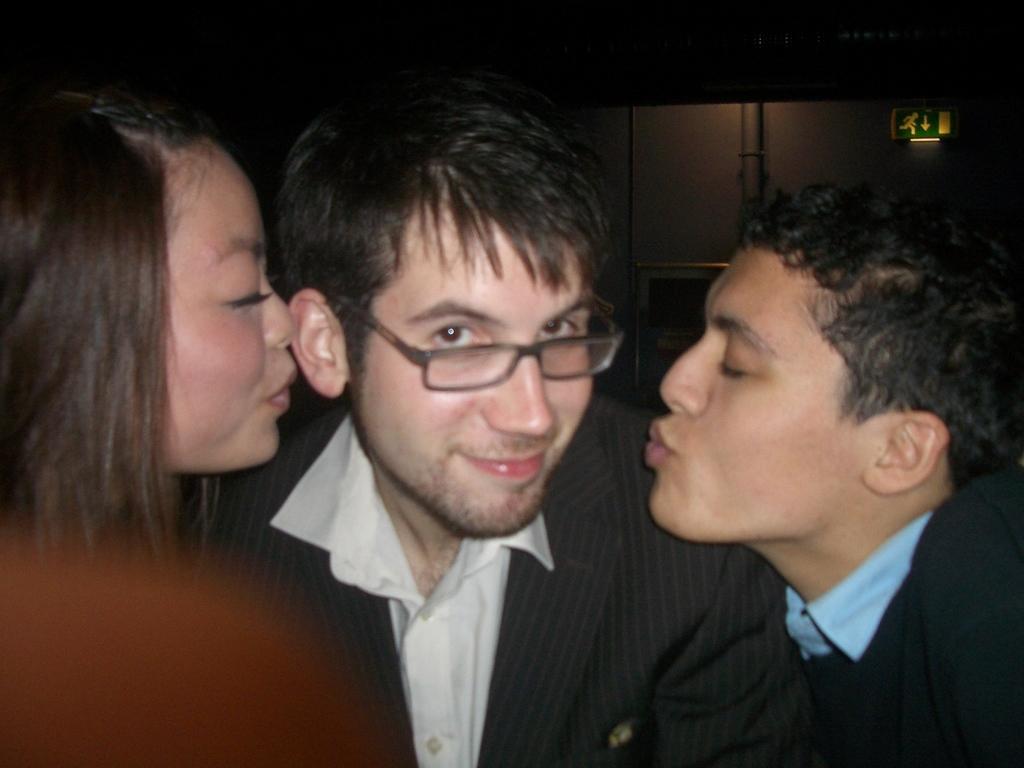Please provide a concise description of this image. In this image I can see two men and a woman. The man who is in the middle is smiling and giving pose for the picture. It seems like the there two persons are missing this man. The background is in black color. 